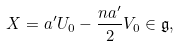Convert formula to latex. <formula><loc_0><loc_0><loc_500><loc_500>X = a ^ { \prime } U _ { 0 } - \frac { n a ^ { \prime } } { 2 } V _ { 0 } \in \mathfrak { g } ,</formula> 